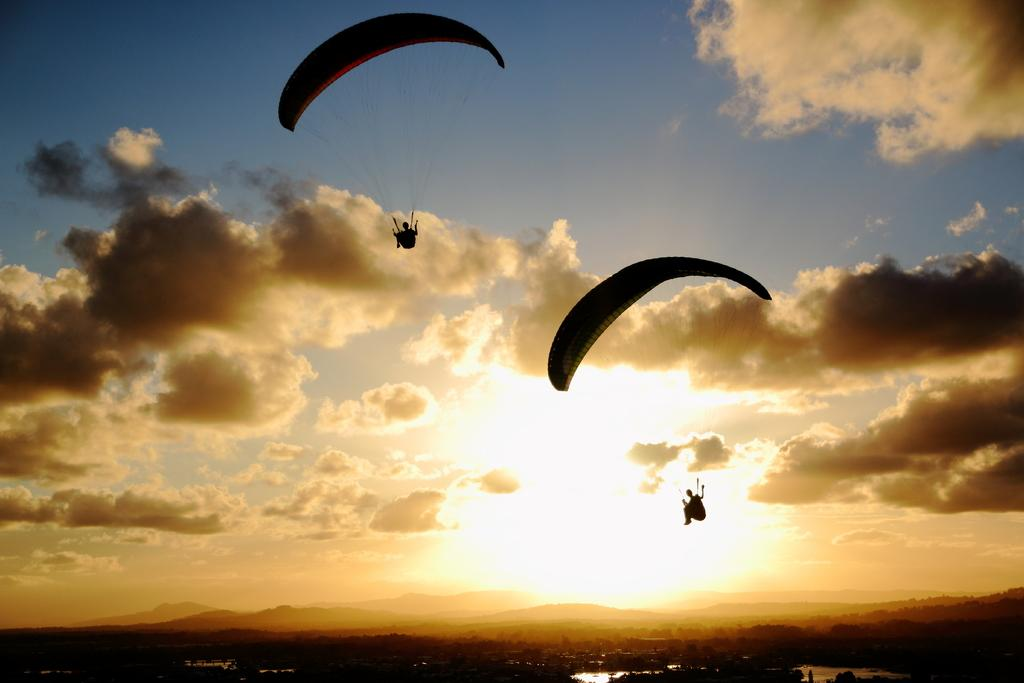How many people are in the image? There are two people in the image. What are the two people doing in the image? The two people are parachuting. What is visible in the background of the image? There is sky and mountains visible in the background of the image. What type of can is being used by the parachuters in the image? There is no can present in the image; the two people are parachuting. How many bikes can be seen in the image? There are no bikes present in the image; the two people are parachuting. 